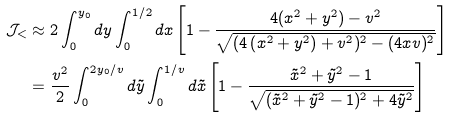Convert formula to latex. <formula><loc_0><loc_0><loc_500><loc_500>\mathcal { J } _ { < } & \approx 2 \int _ { 0 } ^ { y _ { 0 } } d y \int _ { 0 } ^ { 1 / 2 } d x \left [ 1 - \frac { 4 ( x ^ { 2 } + y ^ { 2 } ) - v ^ { 2 } } { \sqrt { ( 4 \left ( x ^ { 2 } + y ^ { 2 } \right ) + v ^ { 2 } ) ^ { 2 } - ( 4 x v ) ^ { 2 } } } \right ] \\ & = \frac { v ^ { 2 } } { 2 } \int _ { 0 } ^ { 2 y _ { 0 } / v } d \tilde { y } \int _ { 0 } ^ { 1 / v } d \tilde { x } \left [ 1 - \frac { \tilde { x } ^ { 2 } + \tilde { y } ^ { 2 } - 1 } { \sqrt { ( \tilde { x } ^ { 2 } + \tilde { y } ^ { 2 } - 1 ) ^ { 2 } + 4 \tilde { y } ^ { 2 } } } \right ]</formula> 